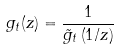<formula> <loc_0><loc_0><loc_500><loc_500>g _ { t } ( z ) = \frac { 1 } { \tilde { g } _ { t } \left ( 1 / z \right ) }</formula> 